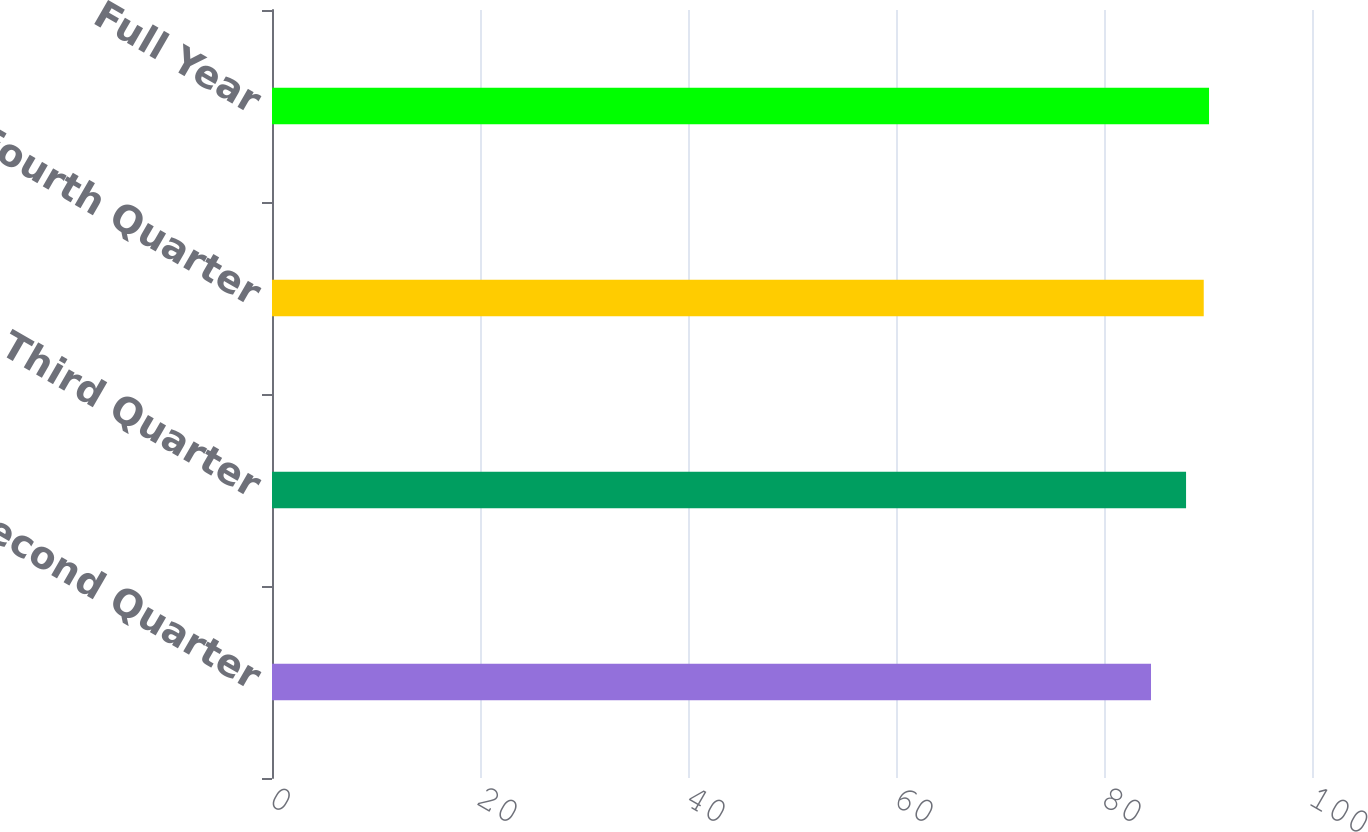Convert chart to OTSL. <chart><loc_0><loc_0><loc_500><loc_500><bar_chart><fcel>Second Quarter<fcel>Third Quarter<fcel>Fourth Quarter<fcel>Full Year<nl><fcel>84.52<fcel>87.89<fcel>89.59<fcel>90.1<nl></chart> 